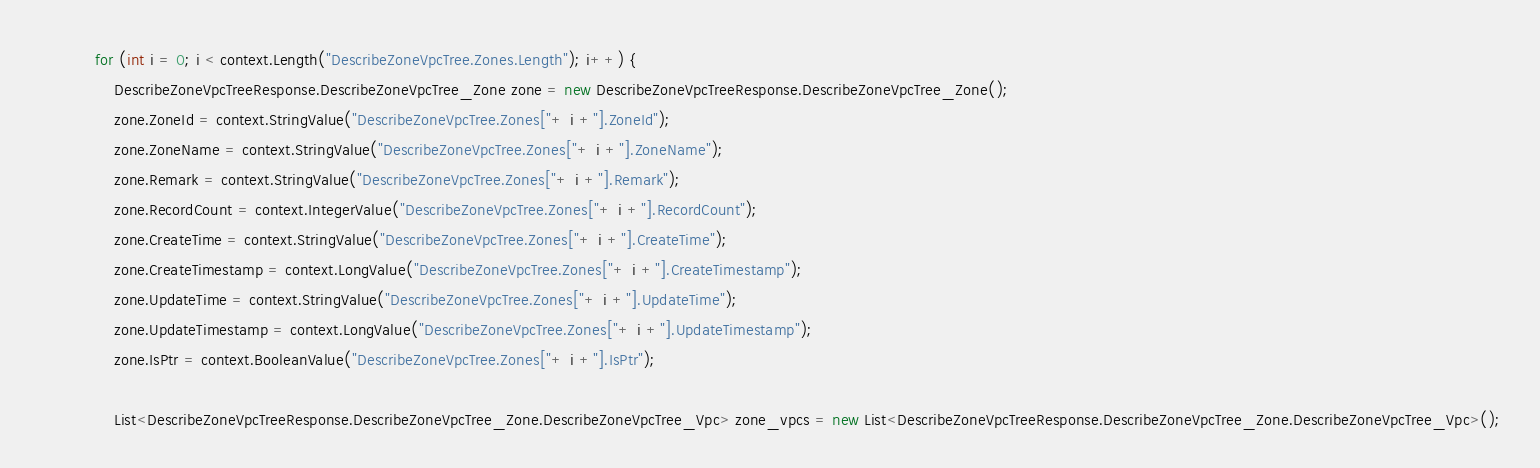Convert code to text. <code><loc_0><loc_0><loc_500><loc_500><_C#_>			for (int i = 0; i < context.Length("DescribeZoneVpcTree.Zones.Length"); i++) {
				DescribeZoneVpcTreeResponse.DescribeZoneVpcTree_Zone zone = new DescribeZoneVpcTreeResponse.DescribeZoneVpcTree_Zone();
				zone.ZoneId = context.StringValue("DescribeZoneVpcTree.Zones["+ i +"].ZoneId");
				zone.ZoneName = context.StringValue("DescribeZoneVpcTree.Zones["+ i +"].ZoneName");
				zone.Remark = context.StringValue("DescribeZoneVpcTree.Zones["+ i +"].Remark");
				zone.RecordCount = context.IntegerValue("DescribeZoneVpcTree.Zones["+ i +"].RecordCount");
				zone.CreateTime = context.StringValue("DescribeZoneVpcTree.Zones["+ i +"].CreateTime");
				zone.CreateTimestamp = context.LongValue("DescribeZoneVpcTree.Zones["+ i +"].CreateTimestamp");
				zone.UpdateTime = context.StringValue("DescribeZoneVpcTree.Zones["+ i +"].UpdateTime");
				zone.UpdateTimestamp = context.LongValue("DescribeZoneVpcTree.Zones["+ i +"].UpdateTimestamp");
				zone.IsPtr = context.BooleanValue("DescribeZoneVpcTree.Zones["+ i +"].IsPtr");

				List<DescribeZoneVpcTreeResponse.DescribeZoneVpcTree_Zone.DescribeZoneVpcTree_Vpc> zone_vpcs = new List<DescribeZoneVpcTreeResponse.DescribeZoneVpcTree_Zone.DescribeZoneVpcTree_Vpc>();</code> 